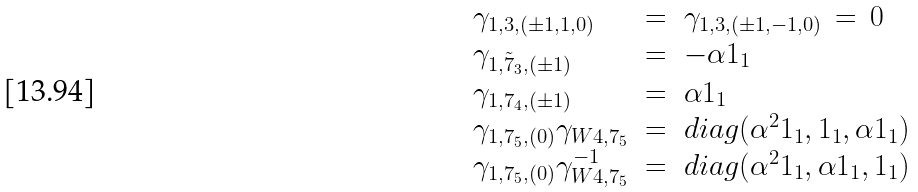Convert formula to latex. <formula><loc_0><loc_0><loc_500><loc_500>\begin{array} { l l l l l } \gamma _ { 1 , 3 , ( \pm 1 , 1 , 0 ) } & = & \gamma _ { 1 , 3 , ( \pm 1 , - 1 , 0 ) } \, = \, { 0 } & & \\ \gamma _ { 1 , { \tilde { 7 } } _ { 3 } , ( \pm 1 ) } & = & - \alpha { 1 } _ { 1 } & & \\ \gamma _ { 1 , 7 _ { 4 } , ( \pm 1 ) } & = & \alpha { 1 } _ { 1 } & & \\ \gamma _ { 1 , 7 _ { 5 } , ( 0 ) } \gamma _ { W 4 , 7 _ { 5 } } & = & d i a g ( \alpha ^ { 2 } { 1 } _ { 1 } , { 1 } _ { 1 } , \alpha { 1 } _ { 1 } ) & & \\ \gamma _ { 1 , 7 _ { 5 } , ( 0 ) } \gamma ^ { - 1 } _ { W 4 , 7 _ { 5 } } & = & d i a g ( \alpha ^ { 2 } { 1 } _ { 1 } , \alpha { 1 } _ { 1 } , { 1 } _ { 1 } ) & & \end{array}</formula> 